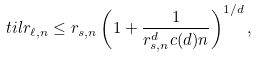<formula> <loc_0><loc_0><loc_500><loc_500>\ t i l { r } _ { \ell , n } \leq r _ { s , n } \left ( 1 + \frac { 1 } { r _ { s , n } ^ { d } c ( d ) n } \right ) ^ { 1 / d } ,</formula> 